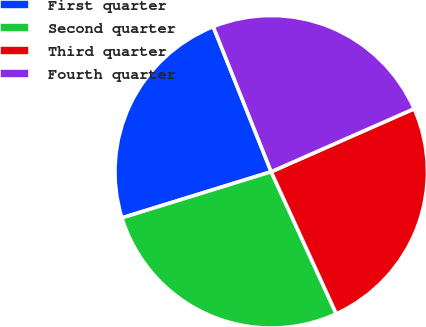<chart> <loc_0><loc_0><loc_500><loc_500><pie_chart><fcel>First quarter<fcel>Second quarter<fcel>Third quarter<fcel>Fourth quarter<nl><fcel>23.72%<fcel>27.07%<fcel>24.77%<fcel>24.44%<nl></chart> 